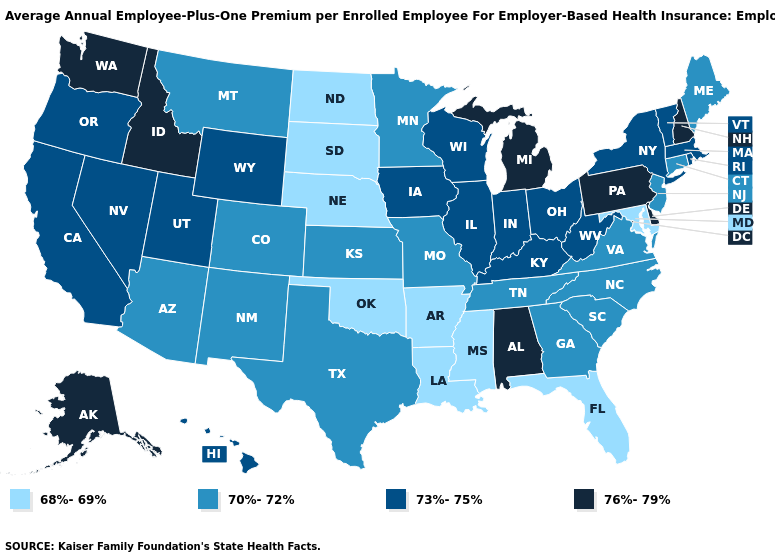What is the value of New Mexico?
Answer briefly. 70%-72%. Name the states that have a value in the range 70%-72%?
Give a very brief answer. Arizona, Colorado, Connecticut, Georgia, Kansas, Maine, Minnesota, Missouri, Montana, New Jersey, New Mexico, North Carolina, South Carolina, Tennessee, Texas, Virginia. Which states have the lowest value in the West?
Answer briefly. Arizona, Colorado, Montana, New Mexico. Name the states that have a value in the range 70%-72%?
Keep it brief. Arizona, Colorado, Connecticut, Georgia, Kansas, Maine, Minnesota, Missouri, Montana, New Jersey, New Mexico, North Carolina, South Carolina, Tennessee, Texas, Virginia. What is the lowest value in the West?
Keep it brief. 70%-72%. Does Oklahoma have a lower value than Louisiana?
Write a very short answer. No. What is the lowest value in the USA?
Keep it brief. 68%-69%. Does Alaska have the same value as Maryland?
Concise answer only. No. Which states have the lowest value in the MidWest?
Be succinct. Nebraska, North Dakota, South Dakota. Name the states that have a value in the range 73%-75%?
Write a very short answer. California, Hawaii, Illinois, Indiana, Iowa, Kentucky, Massachusetts, Nevada, New York, Ohio, Oregon, Rhode Island, Utah, Vermont, West Virginia, Wisconsin, Wyoming. What is the value of Wyoming?
Write a very short answer. 73%-75%. Name the states that have a value in the range 70%-72%?
Quick response, please. Arizona, Colorado, Connecticut, Georgia, Kansas, Maine, Minnesota, Missouri, Montana, New Jersey, New Mexico, North Carolina, South Carolina, Tennessee, Texas, Virginia. What is the highest value in the South ?
Give a very brief answer. 76%-79%. What is the lowest value in states that border New Hampshire?
Keep it brief. 70%-72%. Does Georgia have the highest value in the South?
Be succinct. No. 